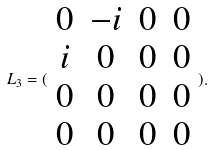Convert formula to latex. <formula><loc_0><loc_0><loc_500><loc_500>L _ { 3 } = ( \begin{array} { c c c c } 0 & - i & 0 & 0 \\ i & 0 & 0 & 0 \\ 0 & 0 & 0 & 0 \\ 0 & 0 & 0 & 0 \end{array} ) .</formula> 